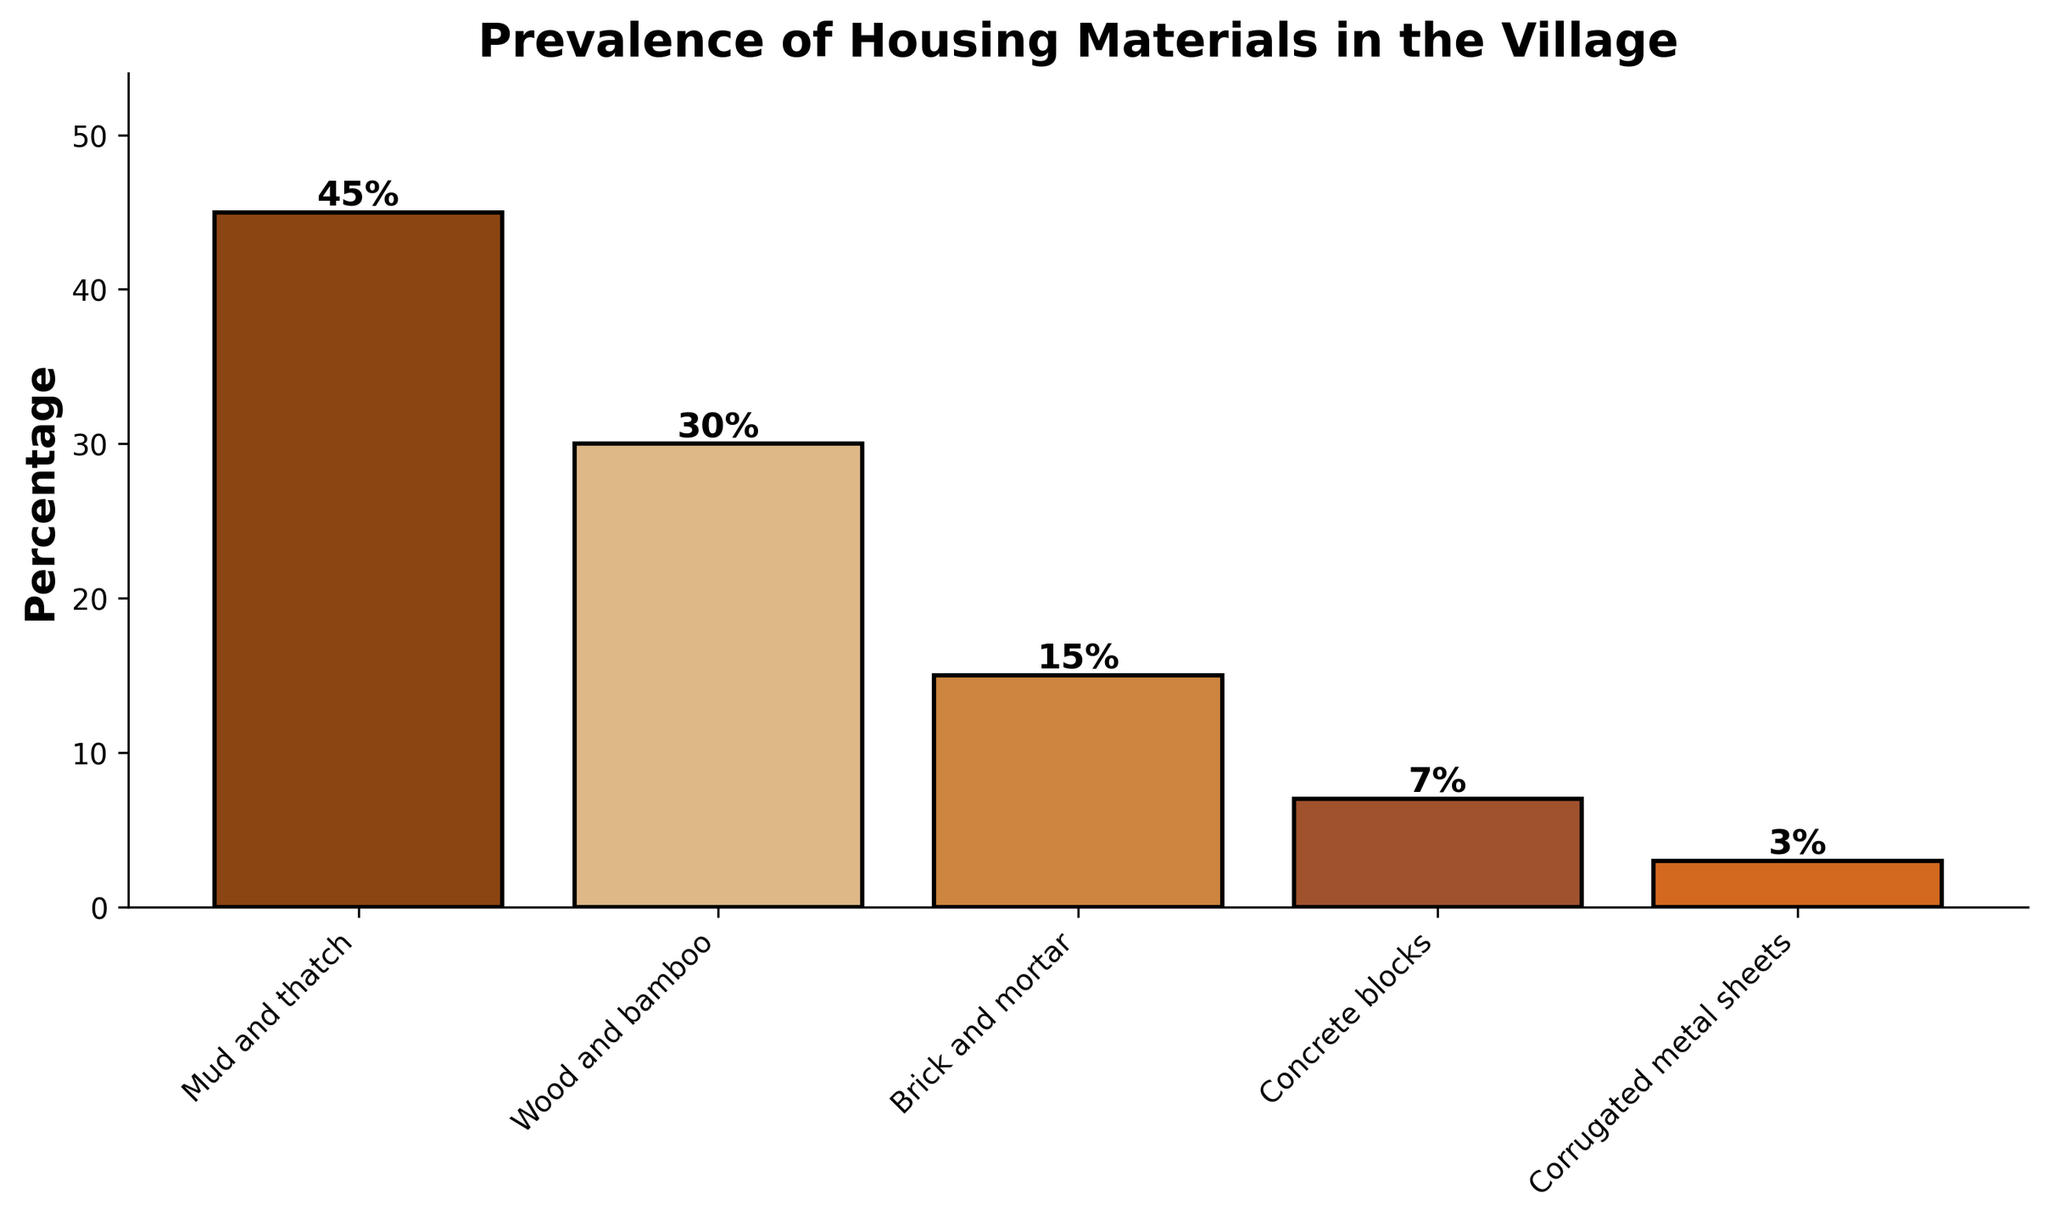What is the most common housing material in the village? The bar with the highest percentage represents the most common housing material. From the figure, "Mud and thatch" has the highest bar with a percentage of 45%.
Answer: Mud and thatch Which housing material is the least prevalent in the village? The bar with the lowest percentage represents the least prevalent housing material. The figure shows "Corrugated metal sheets" has the smallest bar with a percentage of 3%.
Answer: Corrugated metal sheets What is the combined percentage of the three most common housing materials? Identify the three highest bars and sum their percentages. The three most common materials are "Mud and thatch" (45%), "Wood and bamboo" (30%), and "Brick and mortar" (15%). Summing these gives 45% + 30% + 15% = 90%.
Answer: 90% How much more prevalent is "Mud and thatch" compared to "Brick and mortar"? Subtract the percentage of "Brick and mortar" from "Mud and thatch". The percentages are 45% for "Mud and thatch" and 15% for "Brick and mortar". The difference is 45% - 15% = 30%.
Answer: 30% What percentage of houses use materials other than "Mud and thatch"? Subtract the percentage of "Mud and thatch" from 100%. "Mud and thatch" is 45%, so 100% - 45% = 55%.
Answer: 55% Which housing material is more prevalent: "Brick and mortar" or "Concrete blocks"? Compare the heights of the bars for "Brick and mortar" and "Concrete blocks". "Brick and mortar" has a percentage of 15%, while "Concrete blocks" has a percentage of 7%.
Answer: Brick and mortar What is the average percentage of prevalence for all the housing materials? Sum all percentages and divide by the number of categories. The sum (45% + 30% + 15% + 7% + 3%) = 100%. There are 5 categories. The average is 100% / 5 = 20%.
Answer: 20% How many more times prevalent is "Wood and bamboo" than "Concrete blocks"? Divide the percentage of "Wood and bamboo" by the percentage of "Concrete blocks". "Wood and bamboo" has 30% and "Concrete blocks" has 7%. 30% / 7% ≈ 4.29 times.
Answer: 4.29 times If you were to combine "Brick and mortar" and "Concrete blocks," what would be their combined prevalence percentage? Add the percentages of "Brick and mortar" and "Concrete blocks." 15% + 7% = 22%.
Answer: 22% 